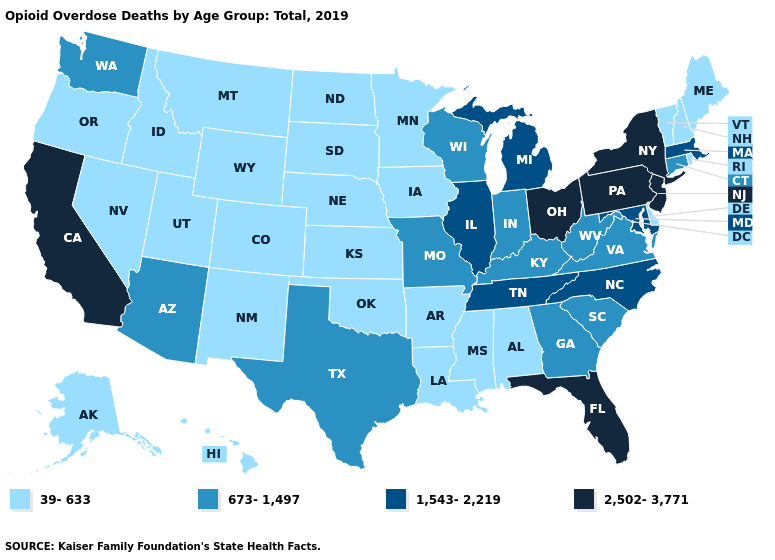What is the value of New Hampshire?
Short answer required. 39-633. Does North Dakota have a higher value than South Dakota?
Keep it brief. No. What is the lowest value in the Northeast?
Write a very short answer. 39-633. Does Florida have the highest value in the USA?
Answer briefly. Yes. Name the states that have a value in the range 673-1,497?
Be succinct. Arizona, Connecticut, Georgia, Indiana, Kentucky, Missouri, South Carolina, Texas, Virginia, Washington, West Virginia, Wisconsin. What is the highest value in the Northeast ?
Answer briefly. 2,502-3,771. What is the value of West Virginia?
Write a very short answer. 673-1,497. Among the states that border Maryland , does Virginia have the highest value?
Be succinct. No. Does the map have missing data?
Concise answer only. No. What is the highest value in the USA?
Concise answer only. 2,502-3,771. Does Washington have the same value as Indiana?
Quick response, please. Yes. Is the legend a continuous bar?
Answer briefly. No. What is the value of South Carolina?
Short answer required. 673-1,497. Name the states that have a value in the range 1,543-2,219?
Answer briefly. Illinois, Maryland, Massachusetts, Michigan, North Carolina, Tennessee. Among the states that border Ohio , does Kentucky have the highest value?
Write a very short answer. No. 